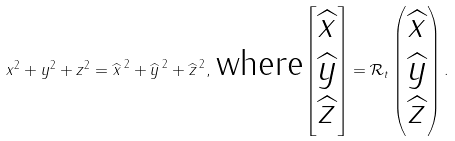<formula> <loc_0><loc_0><loc_500><loc_500>x ^ { 2 } + y ^ { 2 } + z ^ { 2 } = { \widehat { x } \, } ^ { 2 } + { \widehat { y } \, } ^ { 2 } + { \widehat { z } \, } ^ { 2 } , \, \text {where} \begin{bmatrix} \widehat { x } \\ \widehat { y } \\ \widehat { z } \end{bmatrix} = { \mathcal { R } } _ { t } \begin{pmatrix} \widehat { x } \\ \widehat { y } \\ \widehat { z } \end{pmatrix} .</formula> 